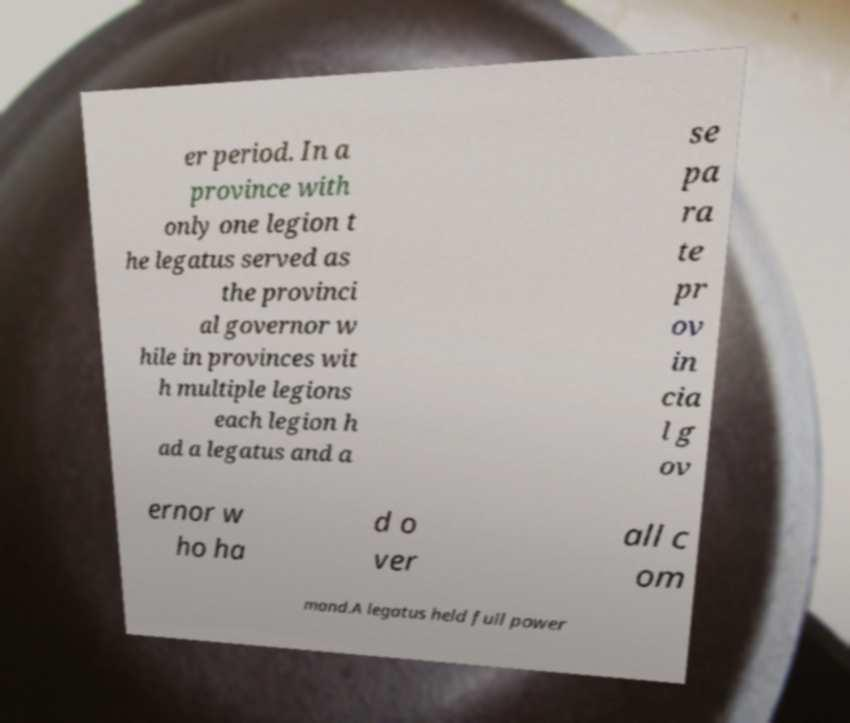Please identify and transcribe the text found in this image. er period. In a province with only one legion t he legatus served as the provinci al governor w hile in provinces wit h multiple legions each legion h ad a legatus and a se pa ra te pr ov in cia l g ov ernor w ho ha d o ver all c om mand.A legatus held full power 